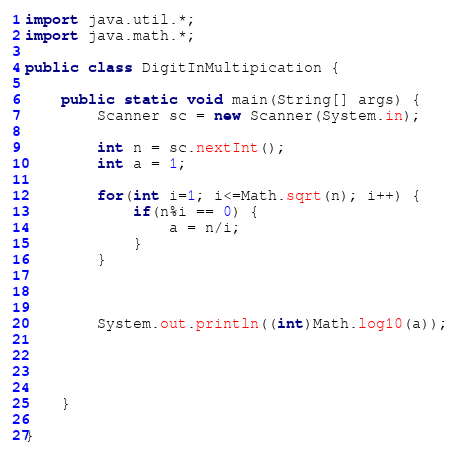<code> <loc_0><loc_0><loc_500><loc_500><_Java_>import java.util.*;
import java.math.*;

public class DigitInMultipication {

	public static void main(String[] args) {
		Scanner sc = new Scanner(System.in);
		
		int n = sc.nextInt();
		int a = 1;	
		
		for(int i=1; i<=Math.sqrt(n); i++) {
			if(n%i == 0) {
				a = n/i;
			}
		}
		
		
		
		System.out.println((int)Math.log10(a));
		
		
		

	}

}
</code> 